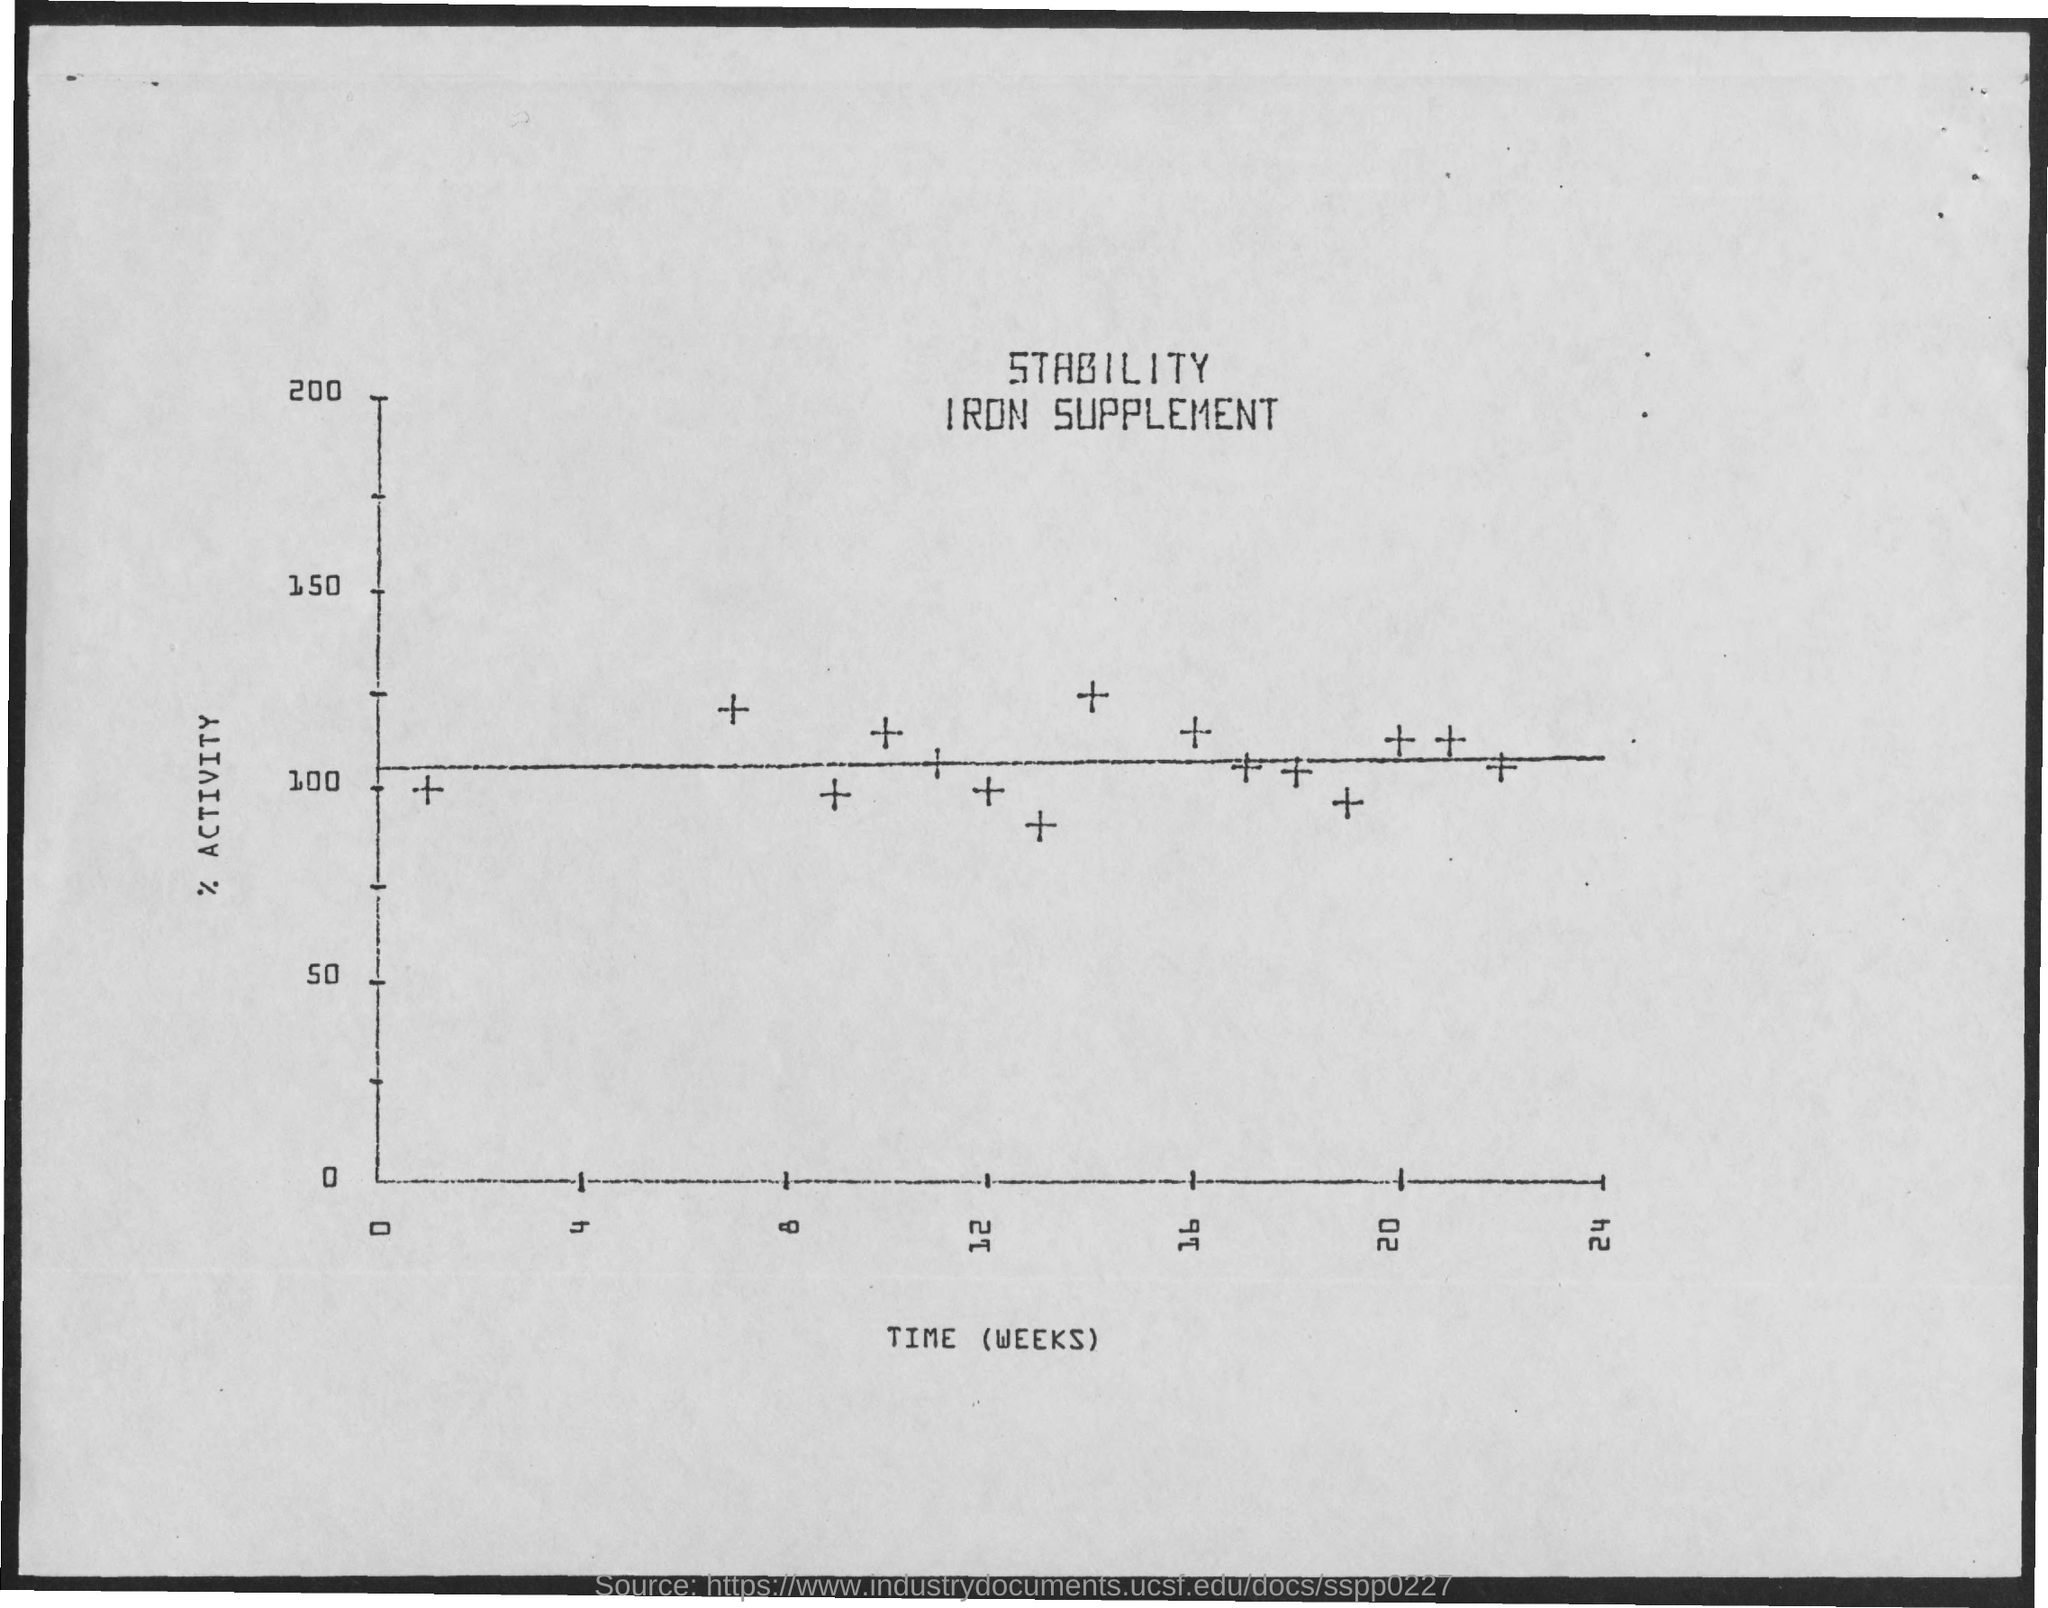Highlight a few significant elements in this photo. The y-axis is used to plot the percentage of activity. The document is titled "Stability Iron Supplement. The x-axis in the plot displays time (weeks). 